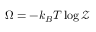<formula> <loc_0><loc_0><loc_500><loc_500>\Omega = - k _ { B } T \log { \mathcal { Z } }</formula> 